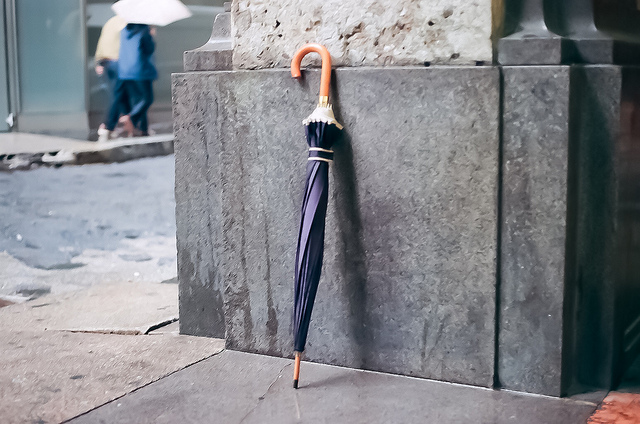How many umbrellas do you see? 1 